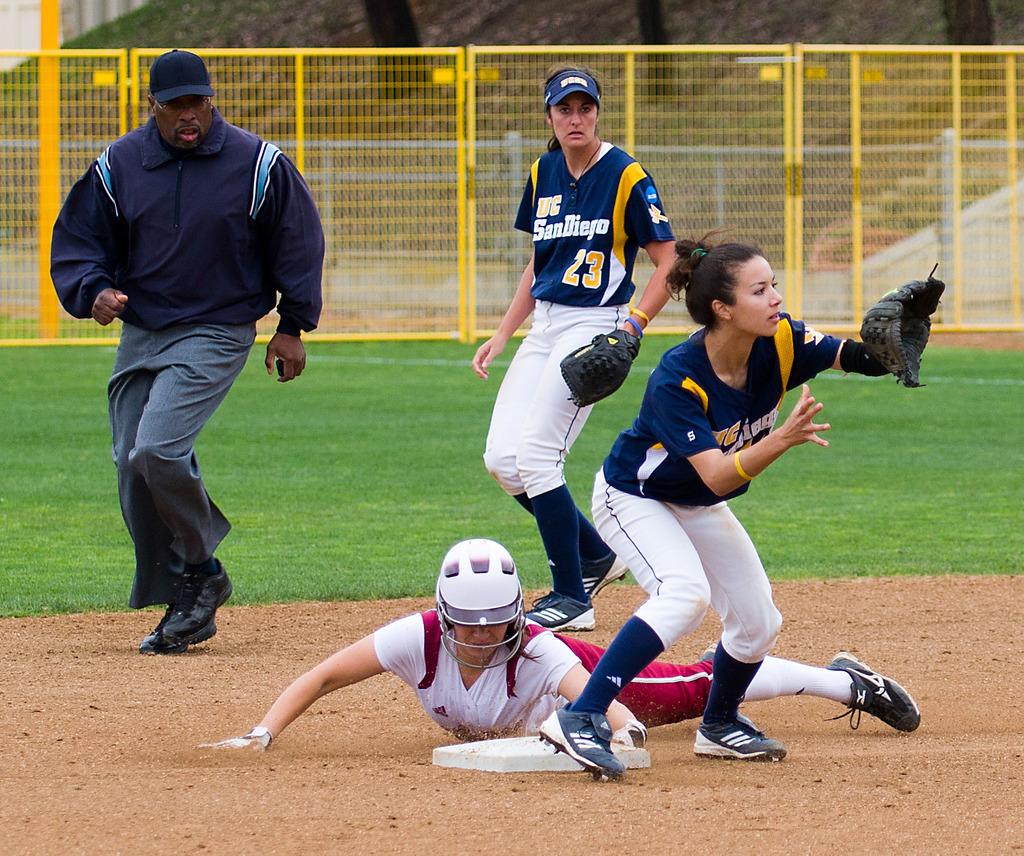What number is on the blue outfit?
Provide a short and direct response. 23. 